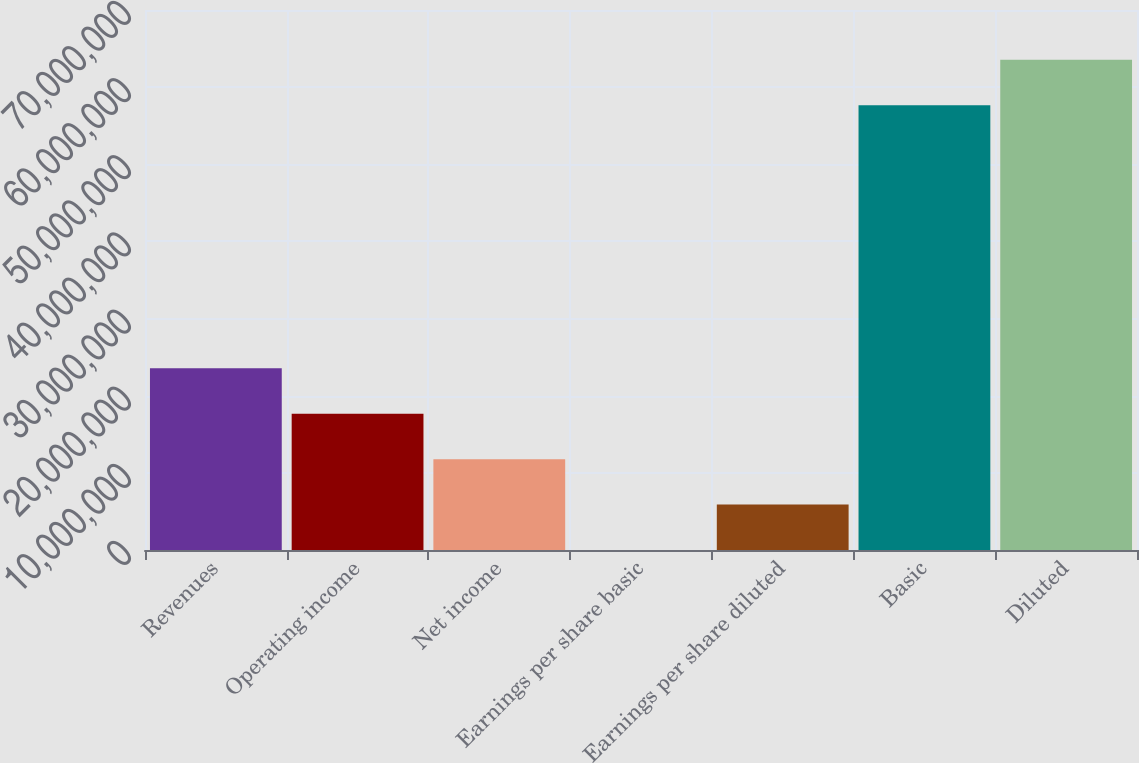<chart> <loc_0><loc_0><loc_500><loc_500><bar_chart><fcel>Revenues<fcel>Operating income<fcel>Net income<fcel>Earnings per share basic<fcel>Earnings per share diluted<fcel>Basic<fcel>Diluted<nl><fcel>2.35532e+07<fcel>1.76649e+07<fcel>1.17766e+07<fcel>0.15<fcel>5.8883e+06<fcel>5.76525e+07<fcel>6.35408e+07<nl></chart> 